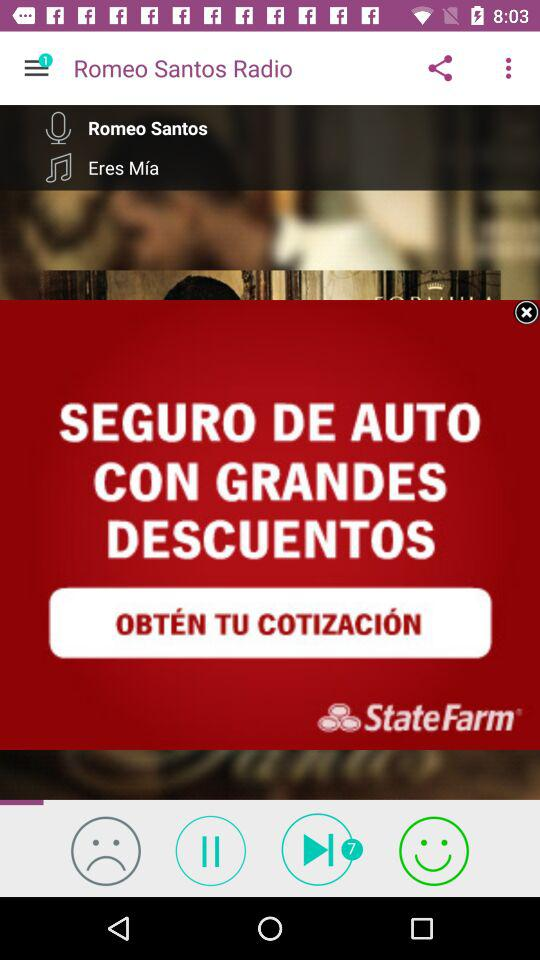What is the time duration of the audio file?
When the provided information is insufficient, respond with <no answer>. <no answer> 